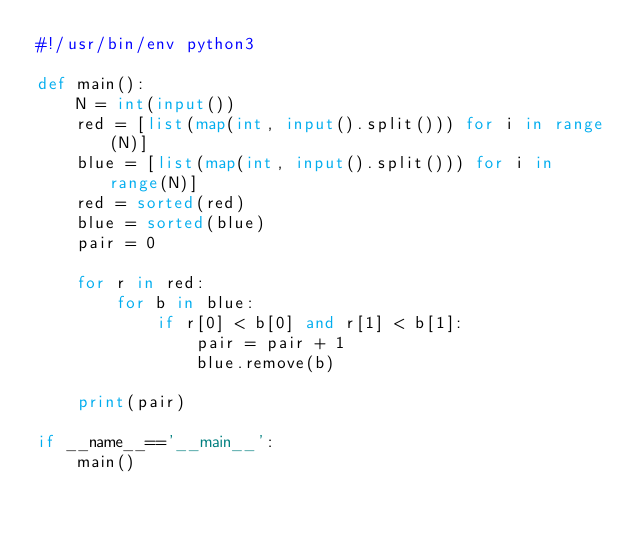<code> <loc_0><loc_0><loc_500><loc_500><_Python_>#!/usr/bin/env python3

def main():
    N = int(input())
    red = [list(map(int, input().split())) for i in range(N)]
    blue = [list(map(int, input().split())) for i in range(N)]
    red = sorted(red)
    blue = sorted(blue)
    pair = 0

    for r in red:
        for b in blue:
            if r[0] < b[0] and r[1] < b[1]:
                pair = pair + 1
                blue.remove(b)

    print(pair)

if __name__=='__main__':
    main()
</code> 